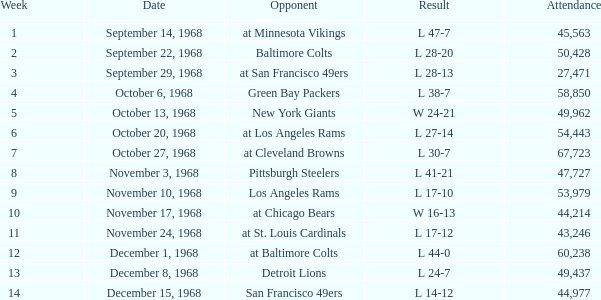Which Attendance has a Date of september 29, 1968, and a Week smaller than 3? None. 